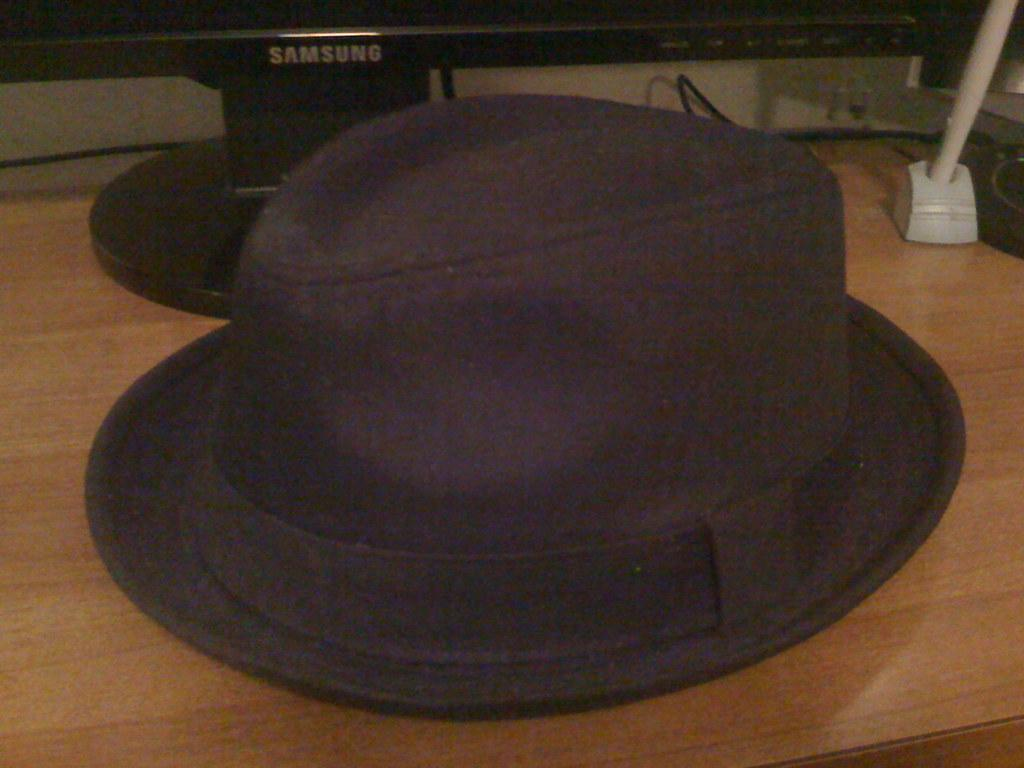What object is placed on the table in the image? There is a hat placed on a table in the image. What electronic device is placed beside the hat in the image? There is a Samsung television placed beside the hat in the image. What type of skirt is draped over the Samsung television in the image? There is no skirt present in the image; it only features a hat and a Samsung television. How does the thumb interact with the hat in the image? There is no thumb present in the image, so it cannot interact with the hat. 